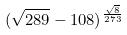Convert formula to latex. <formula><loc_0><loc_0><loc_500><loc_500>( \sqrt { 2 8 9 } - 1 0 8 ) ^ { \frac { \sqrt { 8 } } { 2 7 3 } }</formula> 